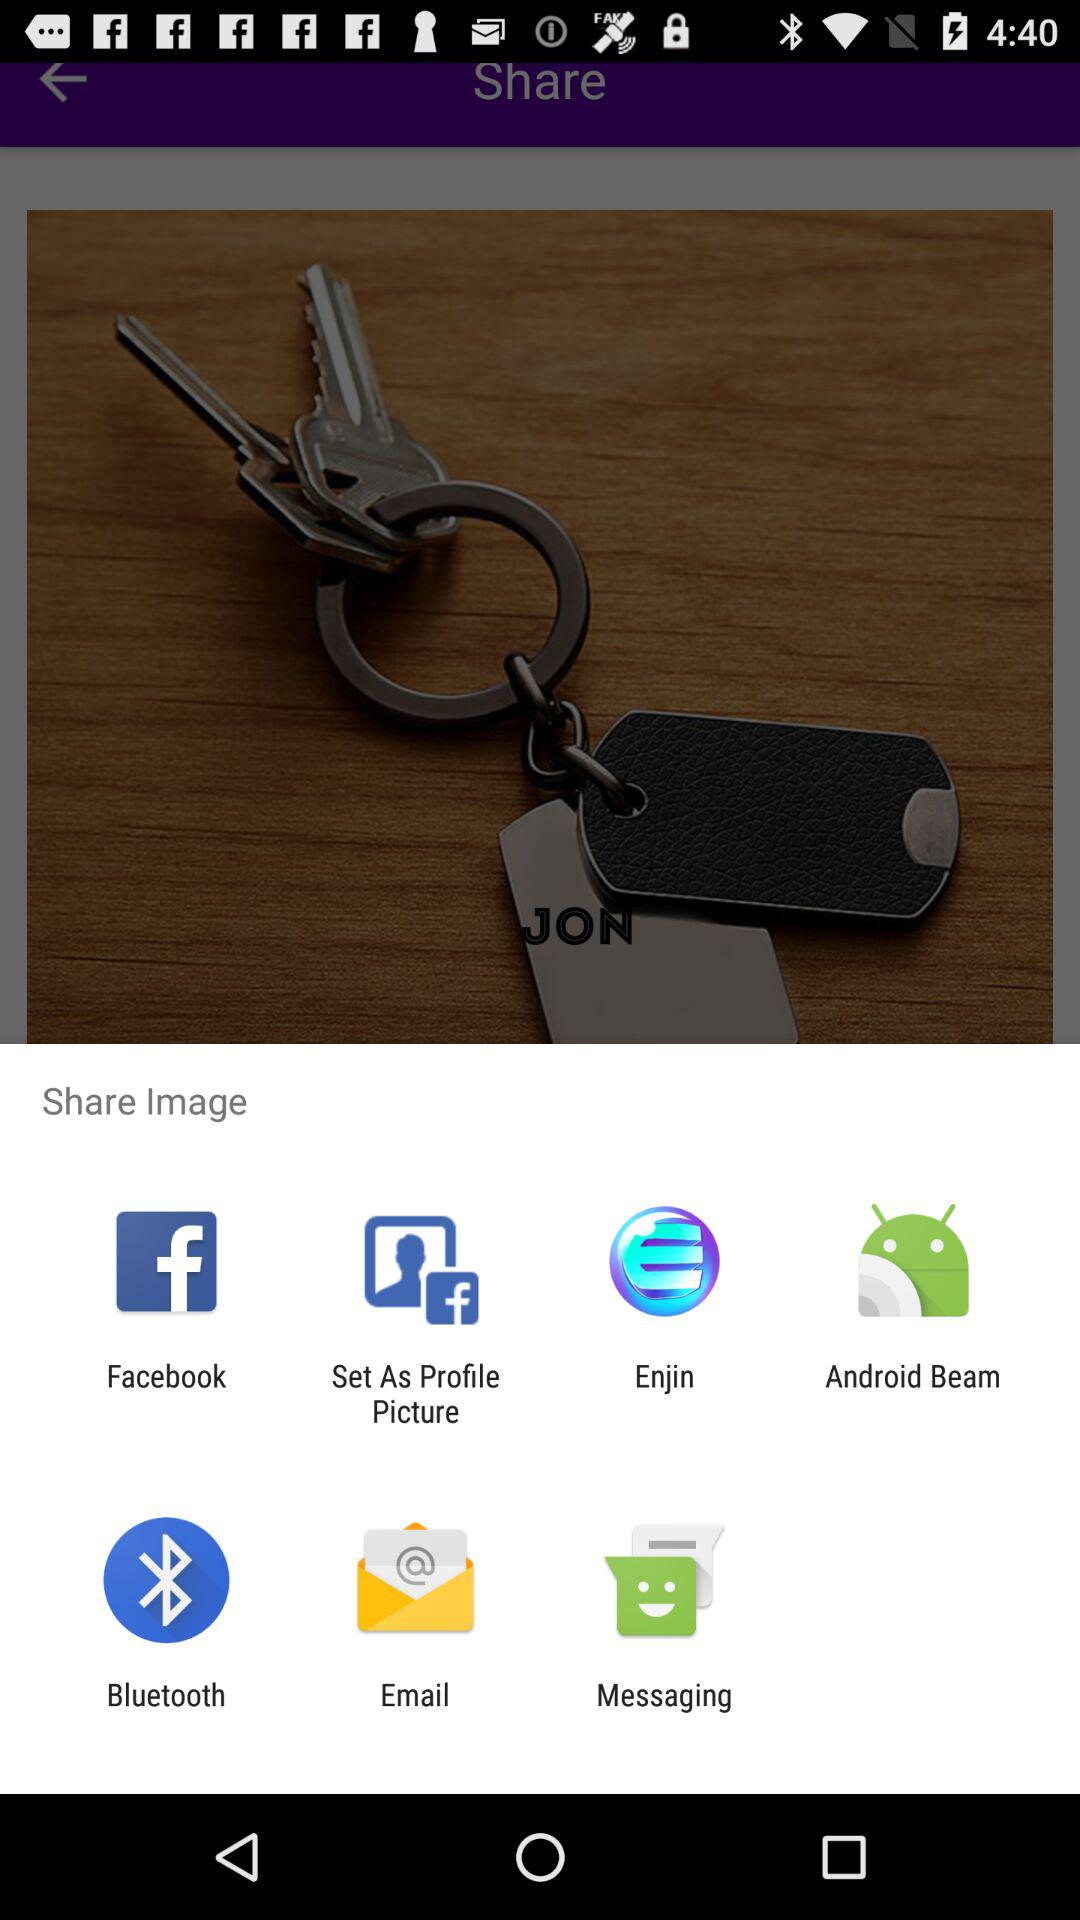Through which application can we share? You can share through "Facebook", "Set As Profile Picture", "Enjin", "Android Beam", "Bluetooth", "Email" and "Messaging". 